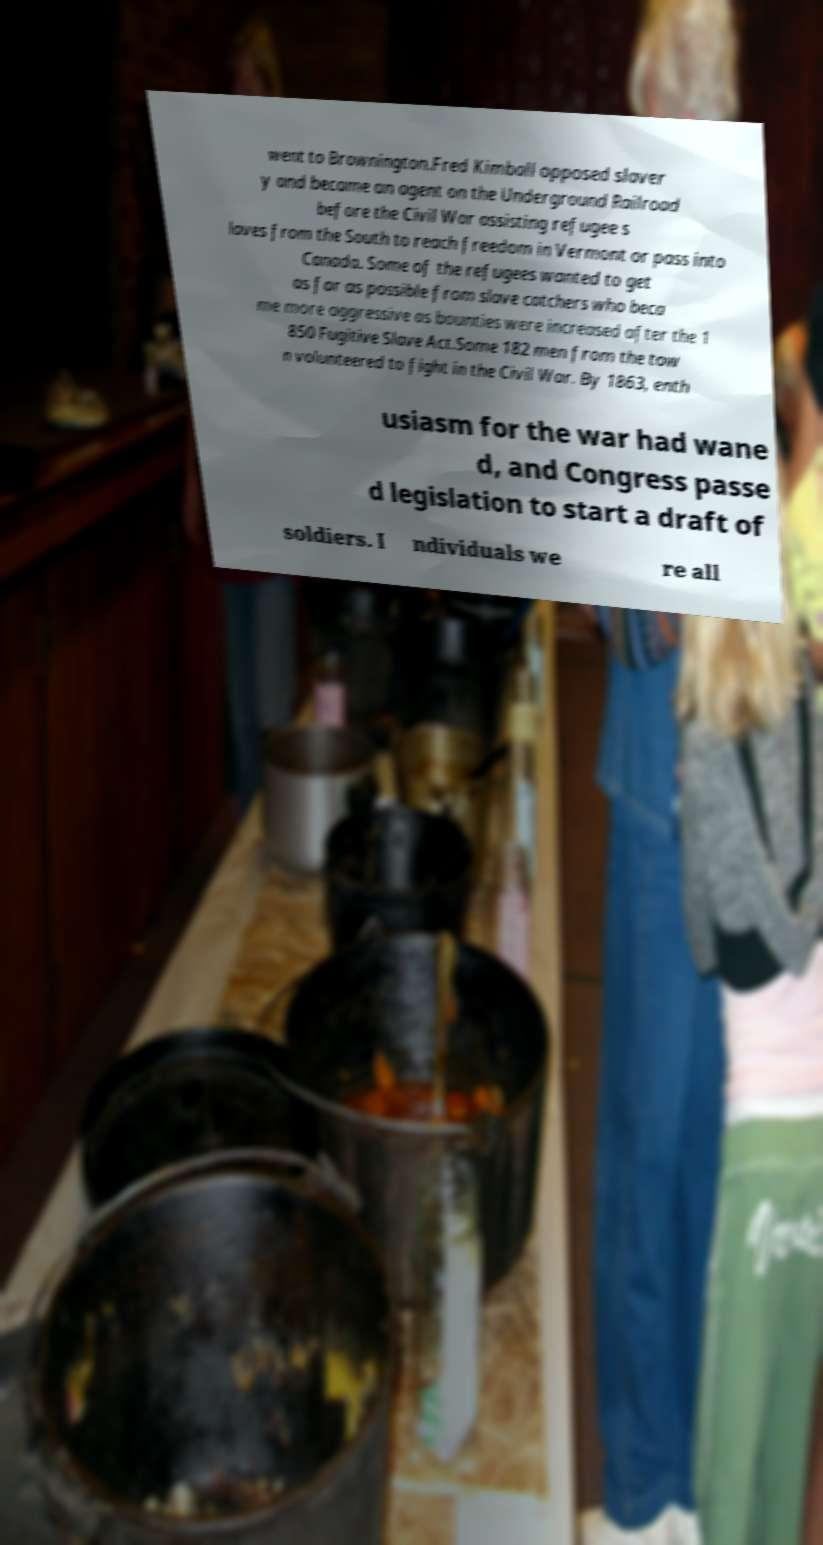Can you read and provide the text displayed in the image?This photo seems to have some interesting text. Can you extract and type it out for me? went to Brownington.Fred Kimball opposed slaver y and became an agent on the Underground Railroad before the Civil War assisting refugee s laves from the South to reach freedom in Vermont or pass into Canada. Some of the refugees wanted to get as far as possible from slave catchers who beca me more aggressive as bounties were increased after the 1 850 Fugitive Slave Act.Some 182 men from the tow n volunteered to fight in the Civil War. By 1863, enth usiasm for the war had wane d, and Congress passe d legislation to start a draft of soldiers. I ndividuals we re all 